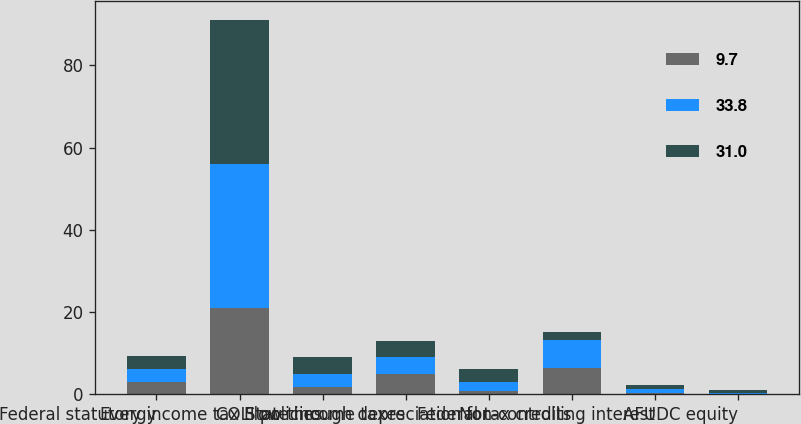Convert chart. <chart><loc_0><loc_0><loc_500><loc_500><stacked_bar_chart><ecel><fcel>Evergy<fcel>Federal statutory income tax<fcel>COLI policies<fcel>State income taxes<fcel>Flow through depreciation for<fcel>Federal tax credits<fcel>Non-controlling interest<fcel>AFUDC equity<nl><fcel>9.7<fcel>3.1<fcel>21<fcel>1.9<fcel>4.9<fcel>0.8<fcel>6.4<fcel>0.4<fcel>0.1<nl><fcel>33.8<fcel>3.1<fcel>35<fcel>3.1<fcel>4.1<fcel>2.3<fcel>6.9<fcel>0.9<fcel>0.2<nl><fcel>31<fcel>3.1<fcel>35<fcel>4.2<fcel>4<fcel>3.1<fcel>1.8<fcel>0.9<fcel>0.8<nl></chart> 